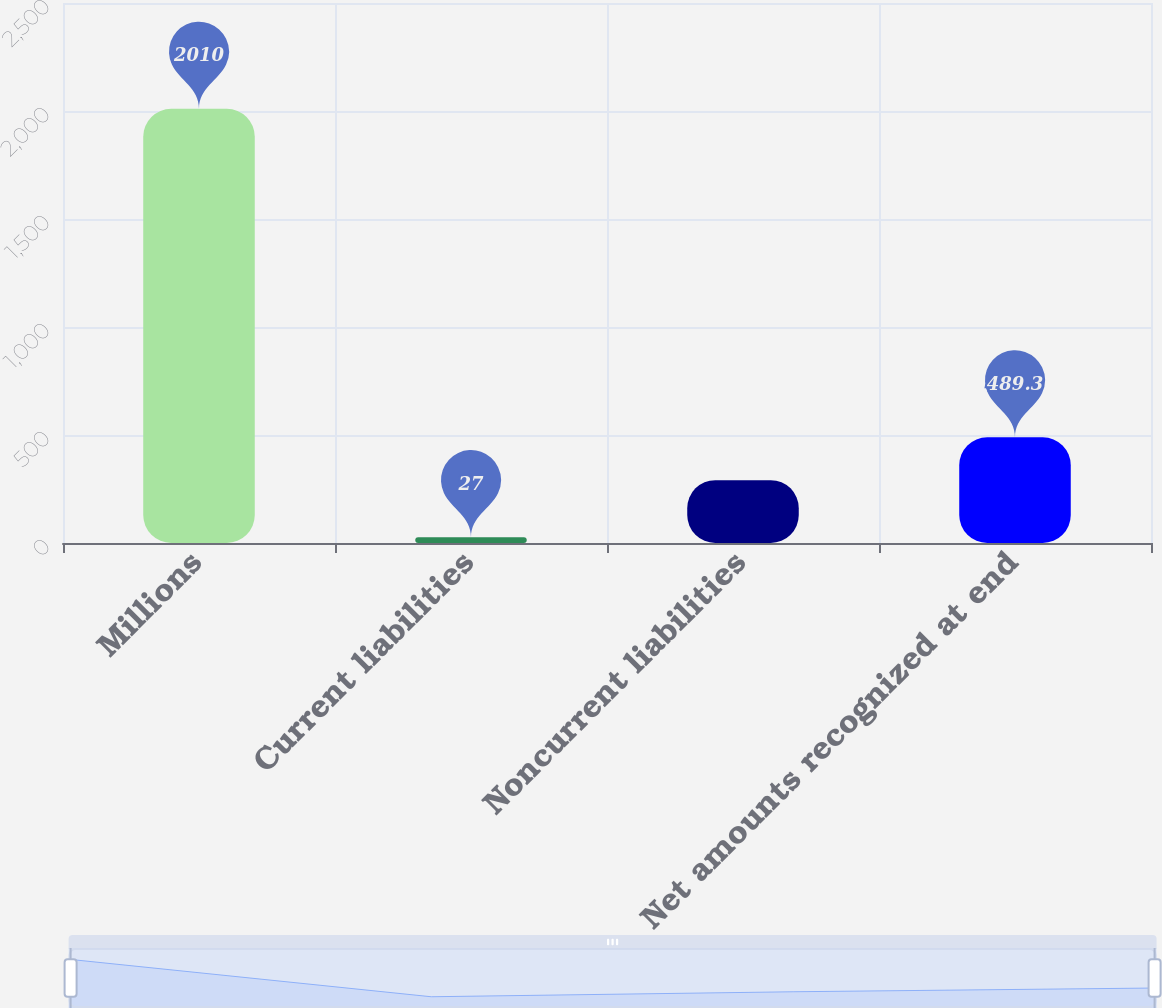<chart> <loc_0><loc_0><loc_500><loc_500><bar_chart><fcel>Millions<fcel>Current liabilities<fcel>Noncurrent liabilities<fcel>Net amounts recognized at end<nl><fcel>2010<fcel>27<fcel>291<fcel>489.3<nl></chart> 